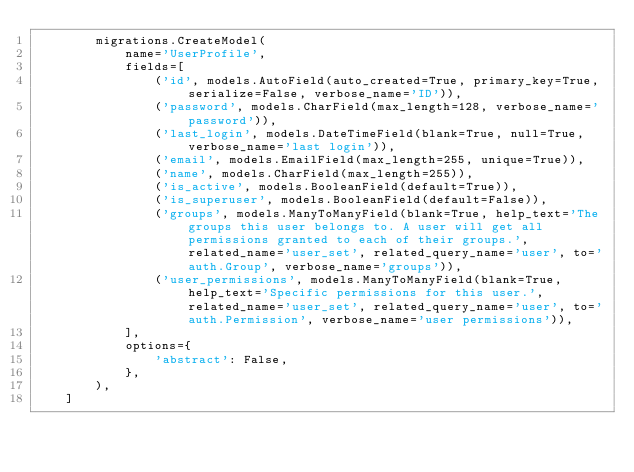Convert code to text. <code><loc_0><loc_0><loc_500><loc_500><_Python_>        migrations.CreateModel(
            name='UserProfile',
            fields=[
                ('id', models.AutoField(auto_created=True, primary_key=True, serialize=False, verbose_name='ID')),
                ('password', models.CharField(max_length=128, verbose_name='password')),
                ('last_login', models.DateTimeField(blank=True, null=True, verbose_name='last login')),
                ('email', models.EmailField(max_length=255, unique=True)),
                ('name', models.CharField(max_length=255)),
                ('is_active', models.BooleanField(default=True)),
                ('is_superuser', models.BooleanField(default=False)),
                ('groups', models.ManyToManyField(blank=True, help_text='The groups this user belongs to. A user will get all permissions granted to each of their groups.', related_name='user_set', related_query_name='user', to='auth.Group', verbose_name='groups')),
                ('user_permissions', models.ManyToManyField(blank=True, help_text='Specific permissions for this user.', related_name='user_set', related_query_name='user', to='auth.Permission', verbose_name='user permissions')),
            ],
            options={
                'abstract': False,
            },
        ),
    ]
</code> 